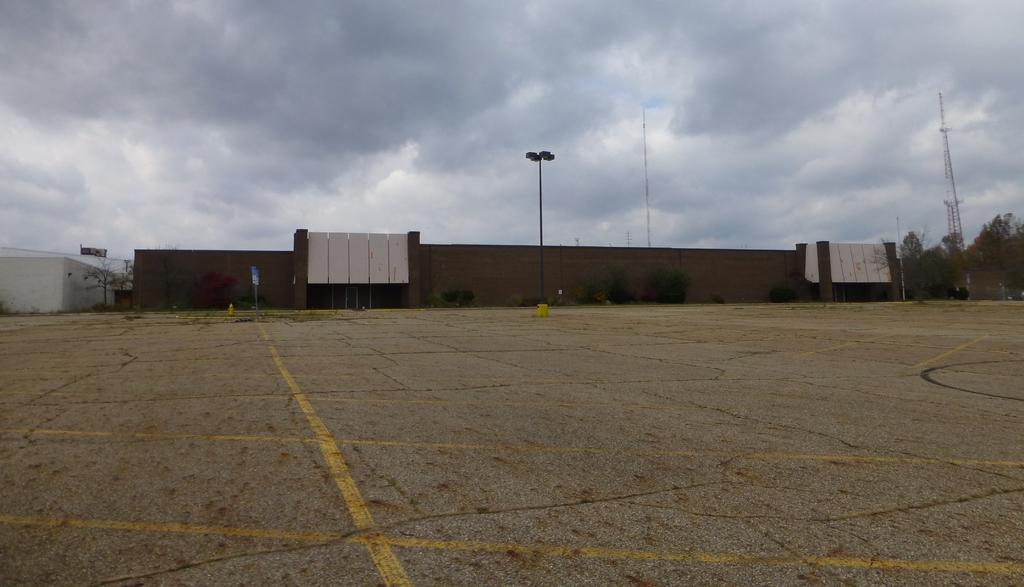Describe this image in one or two sentences. In this picture we can observe a brown color building. We can observe a pole and a tower on the right side. There is a cement floor in front of this building. On the right side there are trees. In the background we can observe a sky with some clouds. 